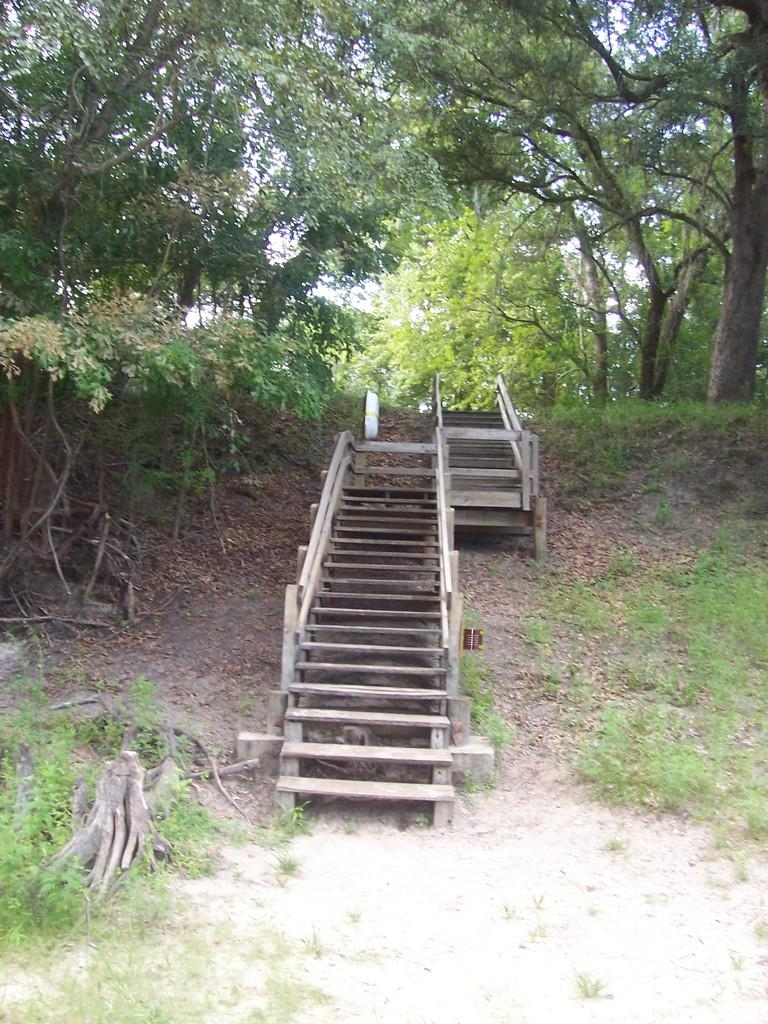What is the main feature in the center of the image? There are stairs in the center of the image. What can be seen in the background of the image? There are trees and logs in the background of the image. What is visible at the bottom of the image? The ground is visible at the bottom of the image. How many fingers can be seen controlling the movement of the logs in the image? There are no fingers or control mechanisms visible in the image; the logs are stationary. 